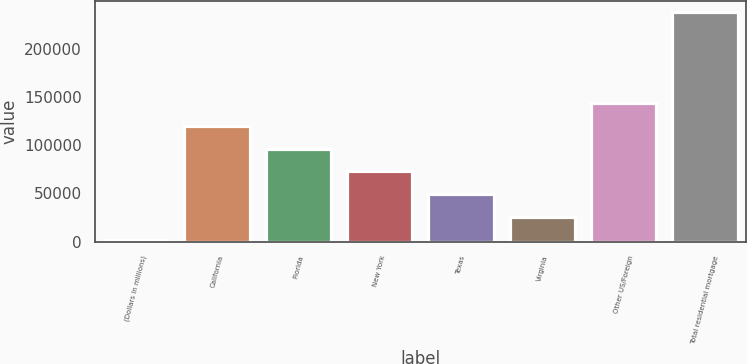<chart> <loc_0><loc_0><loc_500><loc_500><bar_chart><fcel>(Dollars in millions)<fcel>California<fcel>Florida<fcel>New York<fcel>Texas<fcel>Virginia<fcel>Other US/Foreign<fcel>Total residential mortgage<nl><fcel>2008<fcel>120029<fcel>96424.8<fcel>72820.6<fcel>49216.4<fcel>25612.2<fcel>143633<fcel>238050<nl></chart> 